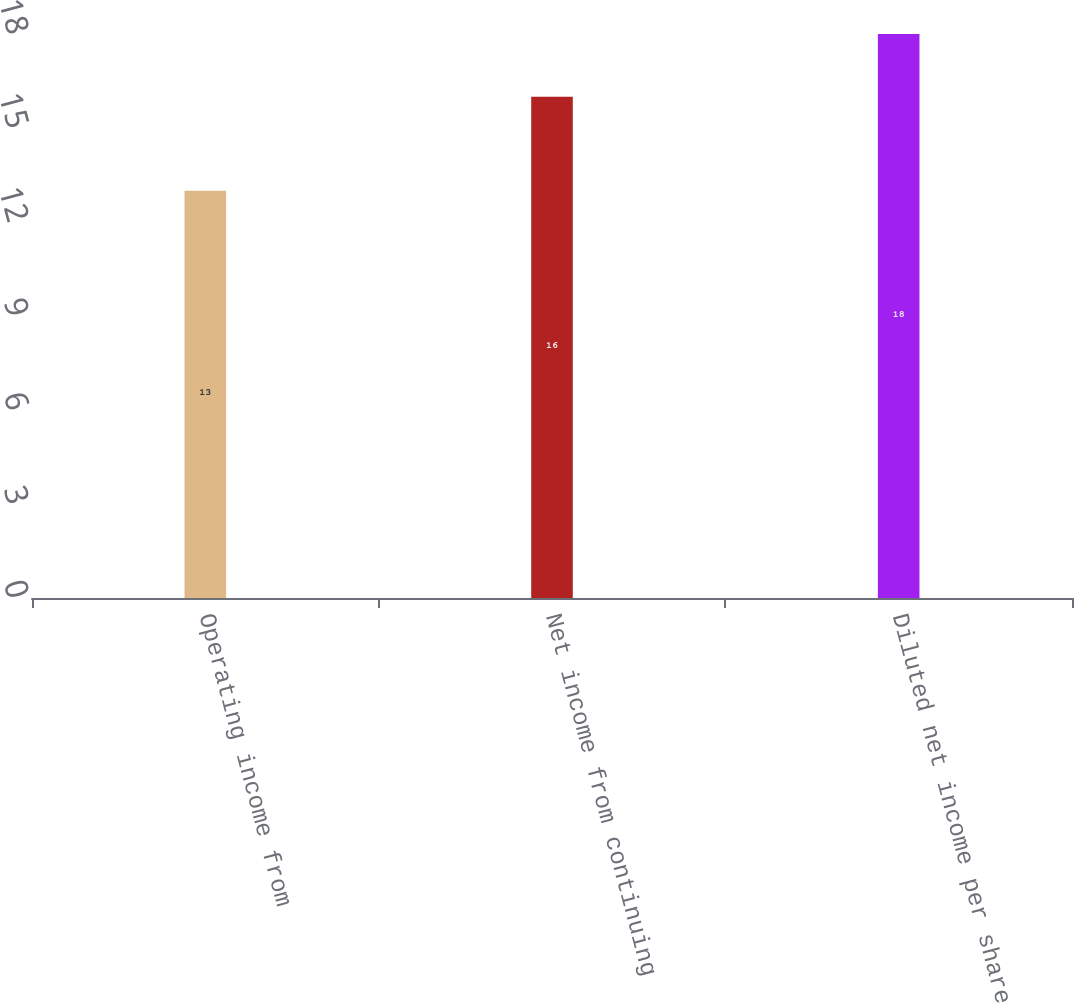Convert chart. <chart><loc_0><loc_0><loc_500><loc_500><bar_chart><fcel>Operating income from<fcel>Net income from continuing<fcel>Diluted net income per share<nl><fcel>13<fcel>16<fcel>18<nl></chart> 